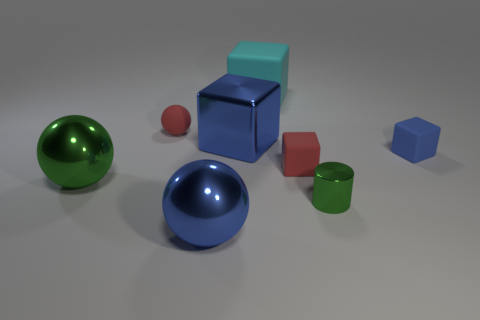Subtract all shiny balls. How many balls are left? 1 Subtract all blue balls. How many blue blocks are left? 2 Subtract 1 cubes. How many cubes are left? 3 Add 2 gray matte blocks. How many objects exist? 10 Subtract all blue balls. How many balls are left? 2 Subtract all cylinders. How many objects are left? 7 Subtract 0 purple cylinders. How many objects are left? 8 Subtract all brown cylinders. Subtract all brown cubes. How many cylinders are left? 1 Subtract all big spheres. Subtract all brown metallic objects. How many objects are left? 6 Add 5 large matte things. How many large matte things are left? 6 